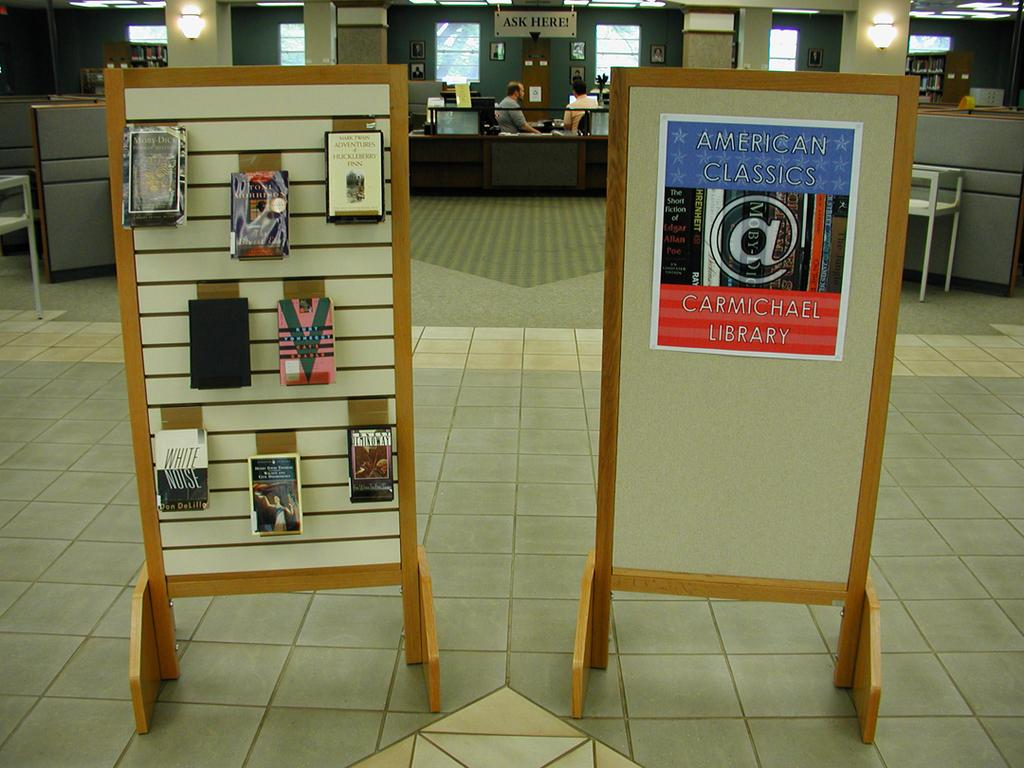<image>
Describe the image concisely. Work area with a sign that states Ask Here with two men sitting below the sign. 